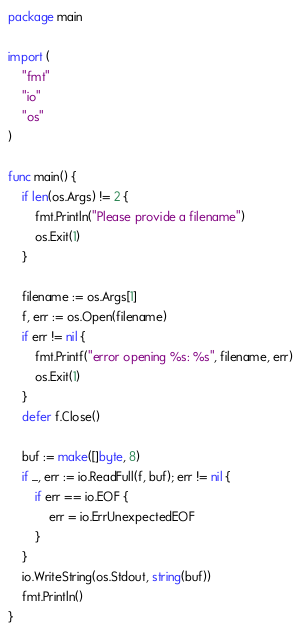<code> <loc_0><loc_0><loc_500><loc_500><_Go_>package main

import (
	"fmt"
	"io"
	"os"
)

func main() {
	if len(os.Args) != 2 {
		fmt.Println("Please provide a filename")
		os.Exit(1)
	}

	filename := os.Args[1]
	f, err := os.Open(filename)
	if err != nil {
		fmt.Printf("error opening %s: %s", filename, err)
		os.Exit(1)
	}
	defer f.Close()

	buf := make([]byte, 8)
	if _, err := io.ReadFull(f, buf); err != nil {
		if err == io.EOF {
			err = io.ErrUnexpectedEOF
		}
	}
	io.WriteString(os.Stdout, string(buf))
	fmt.Println()
}
</code> 